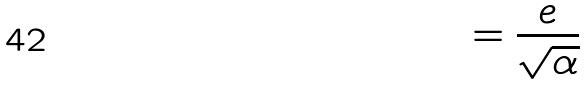Convert formula to latex. <formula><loc_0><loc_0><loc_500><loc_500>= \frac { e } { \sqrt { \alpha } }</formula> 